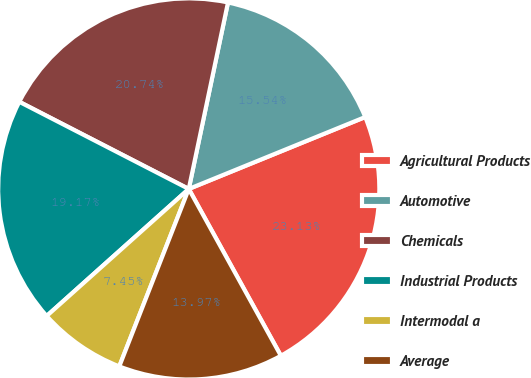Convert chart. <chart><loc_0><loc_0><loc_500><loc_500><pie_chart><fcel>Agricultural Products<fcel>Automotive<fcel>Chemicals<fcel>Industrial Products<fcel>Intermodal a<fcel>Average<nl><fcel>23.13%<fcel>15.54%<fcel>20.74%<fcel>19.17%<fcel>7.45%<fcel>13.97%<nl></chart> 